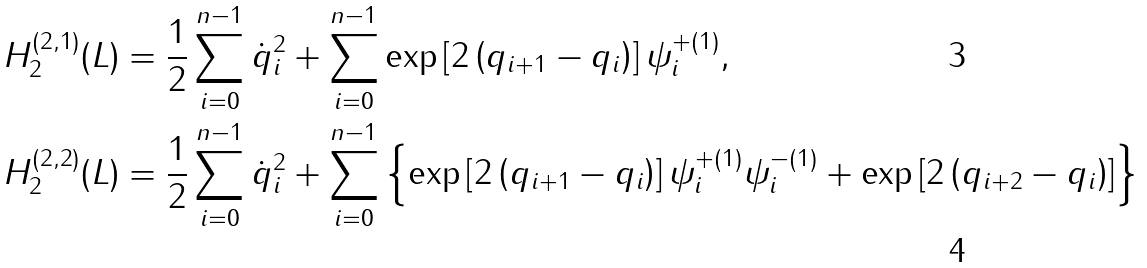<formula> <loc_0><loc_0><loc_500><loc_500>H _ { 2 } ^ { ( 2 , 1 ) } ( L ) & = \frac { 1 } { 2 } \sum _ { i = 0 } ^ { n - 1 } \dot { q } _ { i } ^ { 2 } + \sum _ { i = 0 } ^ { n - 1 } \exp \left [ 2 \left ( q _ { i + 1 } - q _ { i } \right ) \right ] \psi _ { i } ^ { + ( 1 ) } , \quad \\ H _ { 2 } ^ { ( 2 , 2 ) } ( L ) & = \frac { 1 } { 2 } \sum _ { i = 0 } ^ { n - 1 } \dot { q } _ { i } ^ { 2 } + \sum _ { i = 0 } ^ { n - 1 } \left \{ \exp \left [ 2 \left ( q _ { i + 1 } - q _ { i } \right ) \right ] \psi _ { i } ^ { + ( 1 ) } \psi _ { i } ^ { - ( 1 ) } + \exp \left [ 2 \left ( q _ { i + 2 } - q _ { i } \right ) \right ] \right \}</formula> 